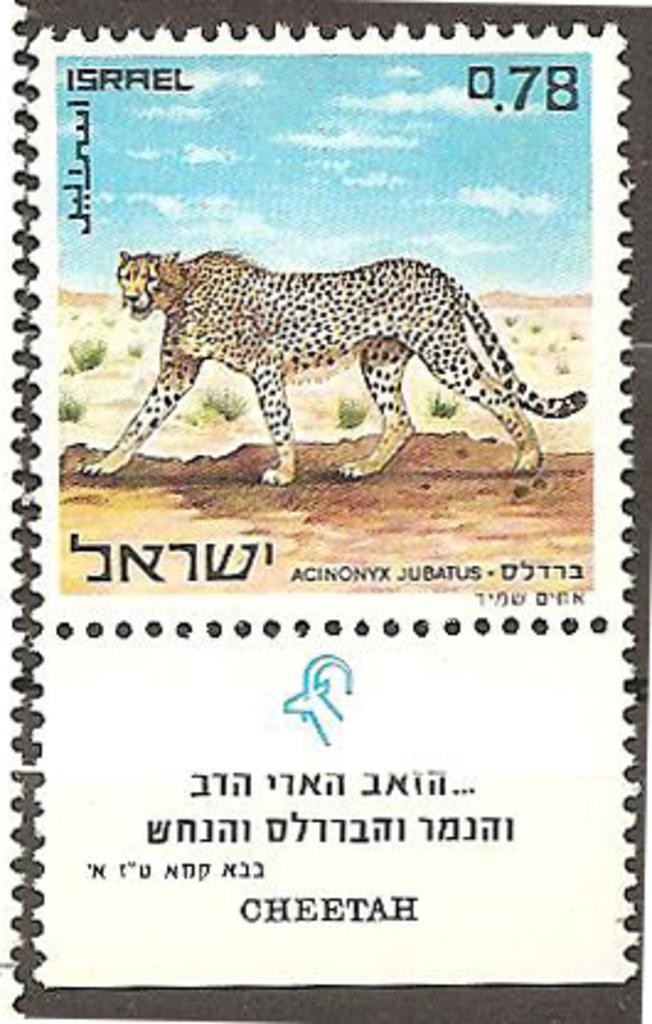What is present on the poster in the image? There is a poster in the image, and it contains a chitha. What is depicted in the chitha on the poster? The chitha depicts the sky. Where is the throne located in the image? There is no throne present in the image. What type of net is visible in the image? There is no net present in the image. Is there a maid in the image? There is no maid present in the image. 